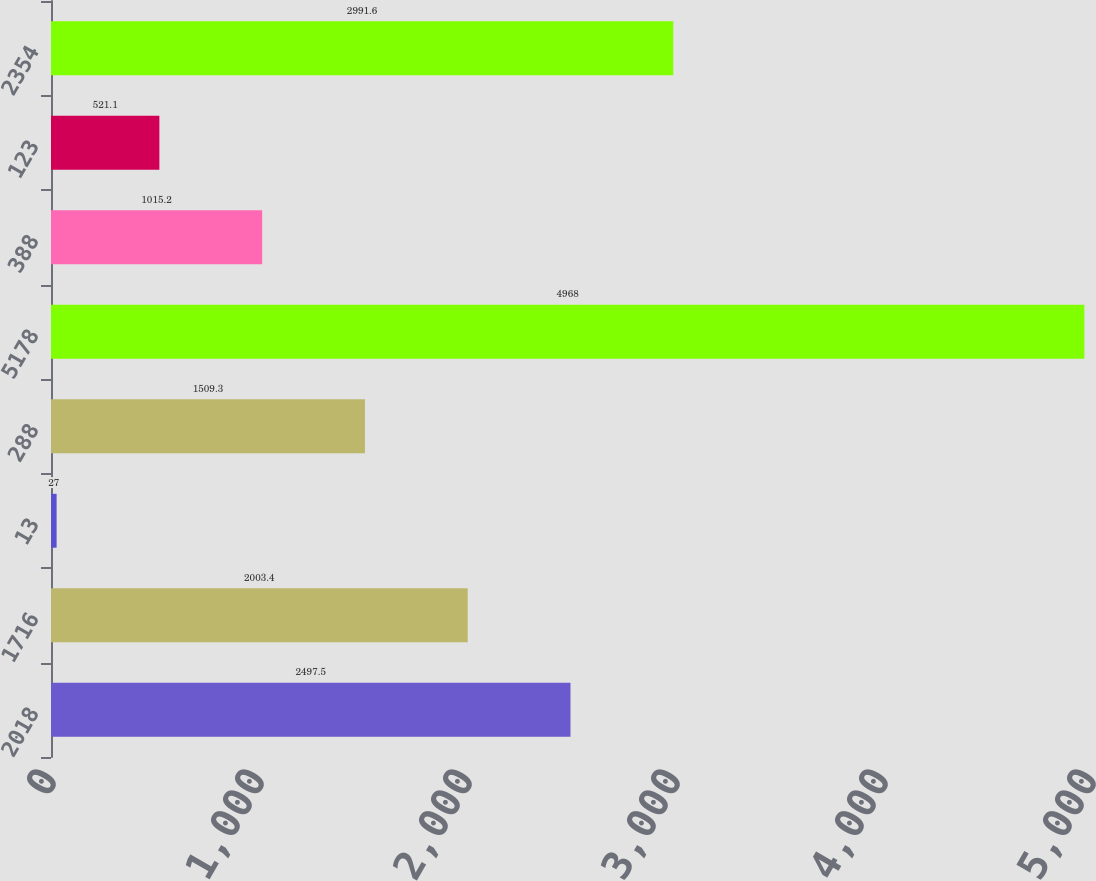Convert chart. <chart><loc_0><loc_0><loc_500><loc_500><bar_chart><fcel>2018<fcel>1716<fcel>13<fcel>288<fcel>5178<fcel>388<fcel>123<fcel>2354<nl><fcel>2497.5<fcel>2003.4<fcel>27<fcel>1509.3<fcel>4968<fcel>1015.2<fcel>521.1<fcel>2991.6<nl></chart> 